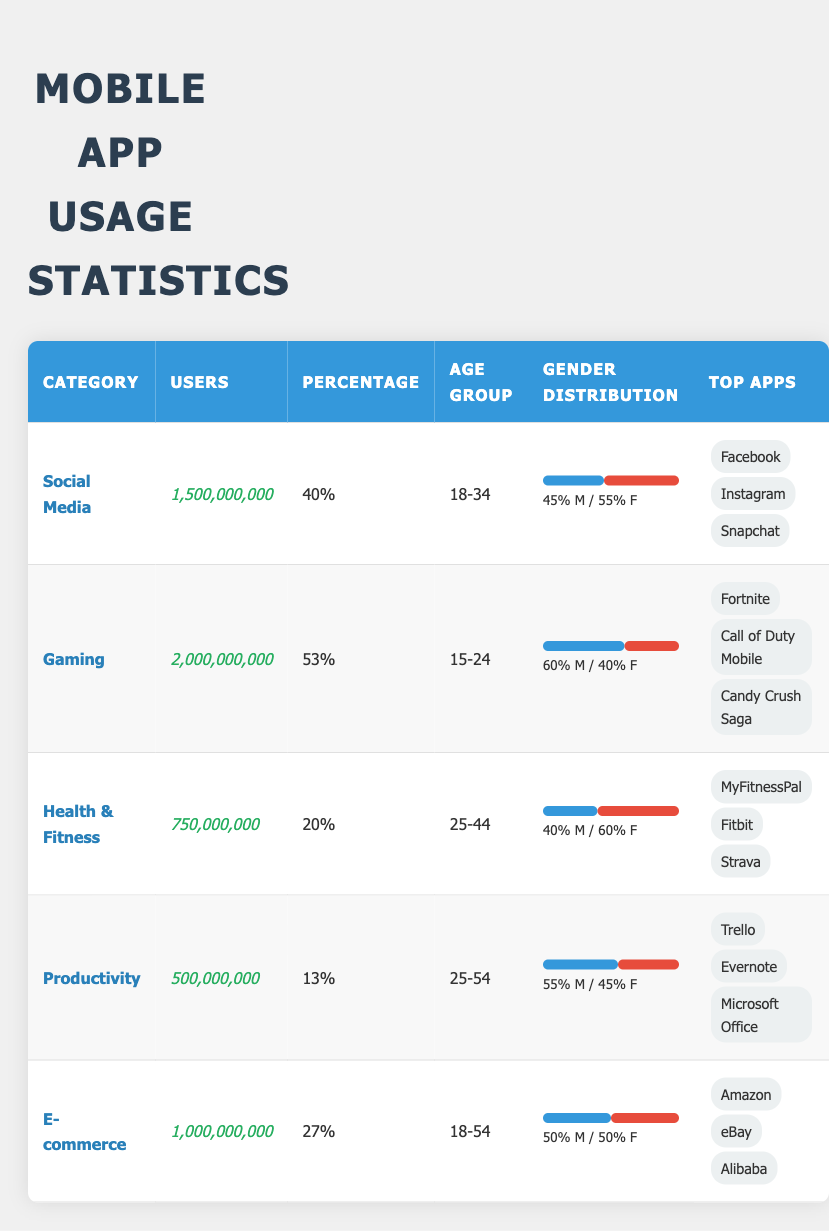What is the total number of users across all categories? To find the total number of users, we can add the number of users in each category: 1,500,000,000 (Social Media) + 2,000,000,000 (Gaming) + 750,000,000 (Health & Fitness) + 500,000,000 (Productivity) + 1,000,000,000 (E-commerce) = 5,750,000,000.
Answer: 5,750,000,000 Which category has the highest percentage of users? Looking at the percentage column, Gaming has the highest percentage at 53%.
Answer: Gaming Is the majority of social media users male? Social Media has a gender distribution of 45% male and 55% female, which means the majority of users are female.
Answer: No How does the user distribution between genders compare in Health & Fitness and Productivity categories? For Health & Fitness, the gender distribution is 40% male and 60% female, while for Productivity, it is 55% male and 45% female. This indicates that Productivity has a higher male user percentage than Health & Fitness.
Answer: Productivity has a higher male user percentage What is the average number of users in the top three categories by user count? The top three categories by user count are Gaming (2,000,000,000), Social Media (1,500,000,000), and E-commerce (1,000,000,000). To find the average, we sum these and divide by three: (2,000,000,000 + 1,500,000,000 + 1,000,000,000) / 3 = 1,500,000,000.
Answer: 1,500,000,000 In which age group do the most users fall? The Gaming category has the highest user count at 2,000,000,000 and its corresponding age group is 15-24. Therefore, the age group with the most users is 15-24.
Answer: 15-24 Are there equal numbers of male and female users in the E-commerce category? The gender distribution in the E-commerce category is 50% male and 50% female, indicating that there are equal numbers of both genders among the users.
Answer: Yes Which category has the lowest percentage of users? The Productivity category has the lowest percentage at 13%.
Answer: Productivity 